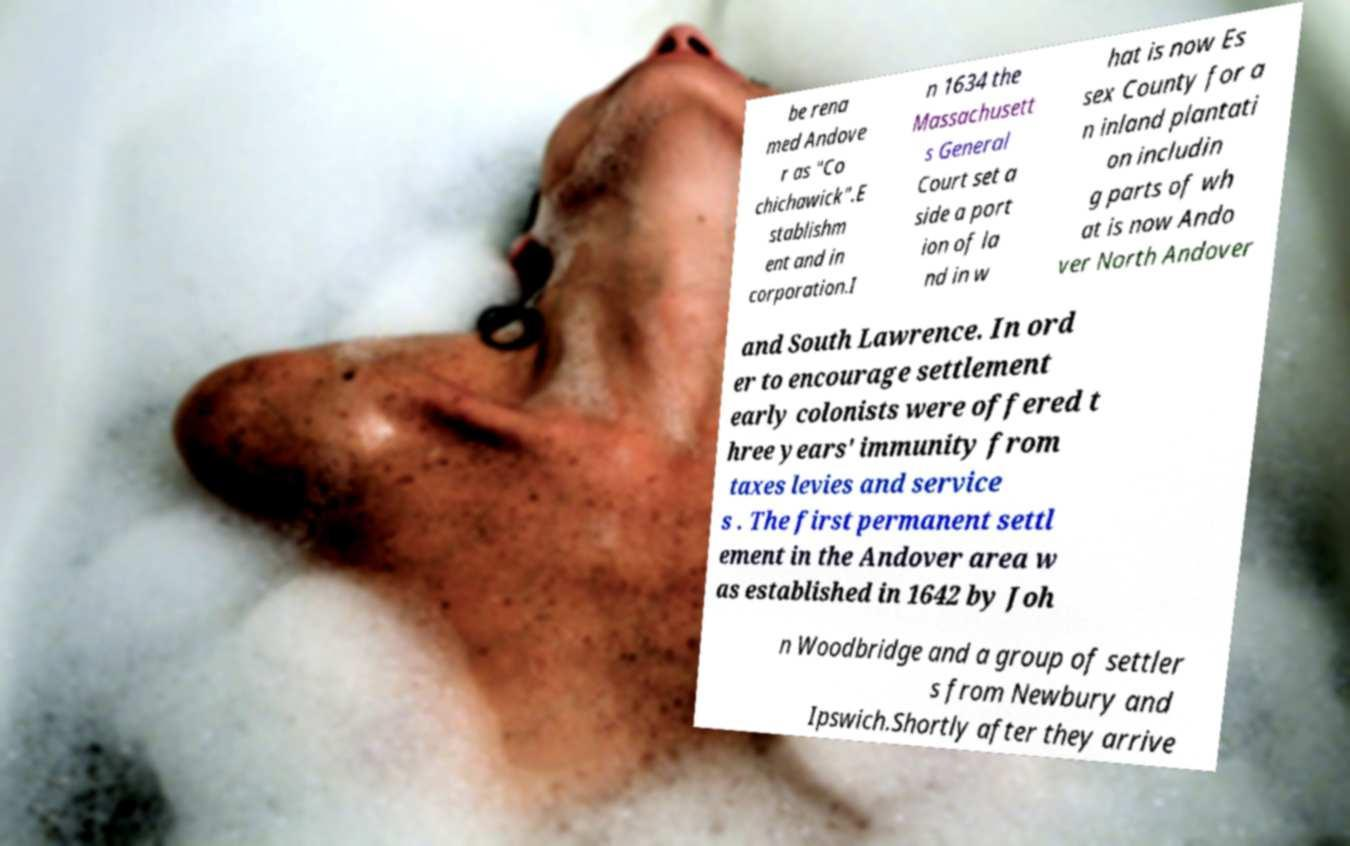For documentation purposes, I need the text within this image transcribed. Could you provide that? be rena med Andove r as "Co chichawick".E stablishm ent and in corporation.I n 1634 the Massachusett s General Court set a side a port ion of la nd in w hat is now Es sex County for a n inland plantati on includin g parts of wh at is now Ando ver North Andover and South Lawrence. In ord er to encourage settlement early colonists were offered t hree years' immunity from taxes levies and service s . The first permanent settl ement in the Andover area w as established in 1642 by Joh n Woodbridge and a group of settler s from Newbury and Ipswich.Shortly after they arrive 